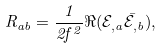Convert formula to latex. <formula><loc_0><loc_0><loc_500><loc_500>R _ { a b } = \frac { 1 } { 2 f ^ { 2 } } \Re ( \mathcal { E } _ { , a } \bar { \mathcal { E } } _ { , b } ) ,</formula> 